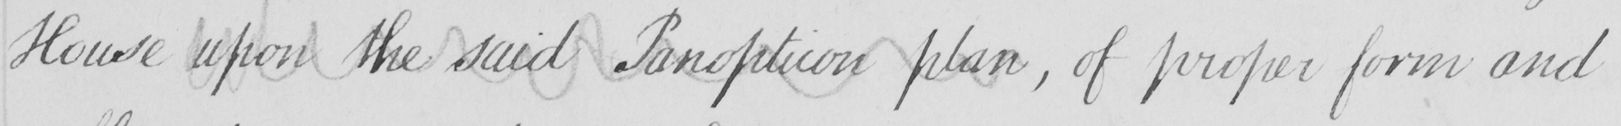Can you tell me what this handwritten text says? House upon the said Panopticon plan , of proper form and 